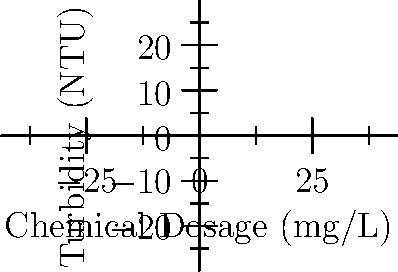Based on the jar test results chart showing the relationship between chemical dosage and turbidity, what is the optimal chemical dosage for achieving the lowest turbidity in the water treatment process? To determine the optimal chemical dosage, we need to follow these steps:

1. Analyze the graph:
   The x-axis represents the chemical dosage in mg/L, and the y-axis represents the turbidity in NTU.

2. Identify the data points:
   - 10 mg/L: 0.8 NTU
   - 20 mg/L: 0.5 NTU
   - 30 mg/L: 0.2 NTU
   - 40 mg/L: 0.3 NTU
   - 50 mg/L: 0.6 NTU

3. Find the lowest turbidity value:
   The lowest turbidity value is 0.2 NTU.

4. Determine the corresponding chemical dosage:
   The chemical dosage that corresponds to the lowest turbidity (0.2 NTU) is 30 mg/L.

Therefore, the optimal chemical dosage for achieving the lowest turbidity in the water treatment process is 30 mg/L.
Answer: 30 mg/L 